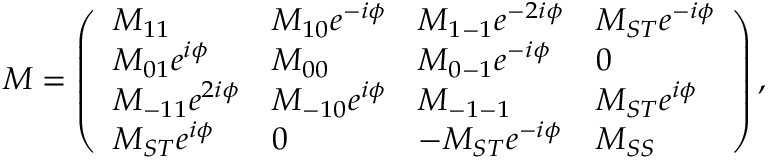Convert formula to latex. <formula><loc_0><loc_0><loc_500><loc_500>\begin{array} { r } { M = \left ( \begin{array} { l l l l } { M _ { 1 1 } } & { M _ { 1 0 } e ^ { - i \phi } } & { M _ { 1 - 1 } e ^ { - 2 i \phi } } & { M _ { S T } e ^ { - i \phi } } \\ { M _ { 0 1 } e ^ { i \phi } } & { M _ { 0 0 } } & { M _ { 0 - 1 } e ^ { - i \phi } } & { 0 } \\ { M _ { - 1 1 } e ^ { 2 i \phi } } & { M _ { - 1 0 } e ^ { i \phi } } & { M _ { - 1 - 1 } } & { M _ { S T } e ^ { i \phi } } \\ { M _ { S T } e ^ { i \phi } } & { 0 } & { - M _ { S T } e ^ { - i \phi } } & { M _ { S S } } \end{array} \right ) , } \end{array}</formula> 